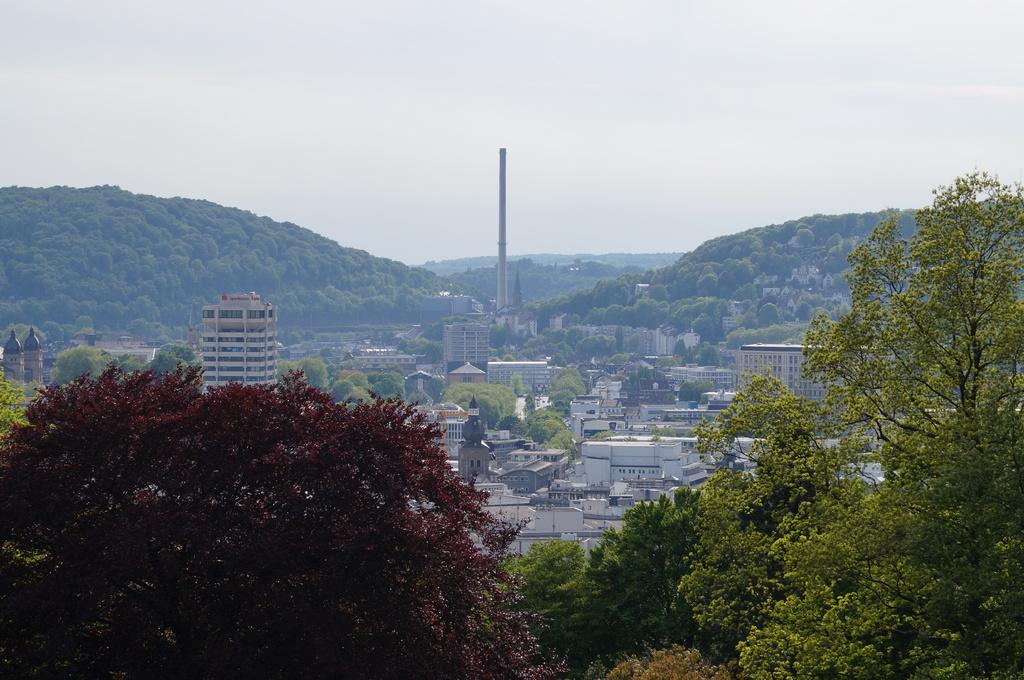What type of natural elements can be seen in the image? There are trees in the image. What type of man-made structures can be seen in the background of the image? There are buildings in the background of the image. What type of geographical features can be seen in the background of the image? There are mountains in the background of the image. What part of the natural environment is visible in the background of the image? The sky is visible in the background of the image. What type of system is present in the cellar of the building in the image? There is no mention of a cellar or any system in the image; it features trees, buildings, mountains, and the sky. 